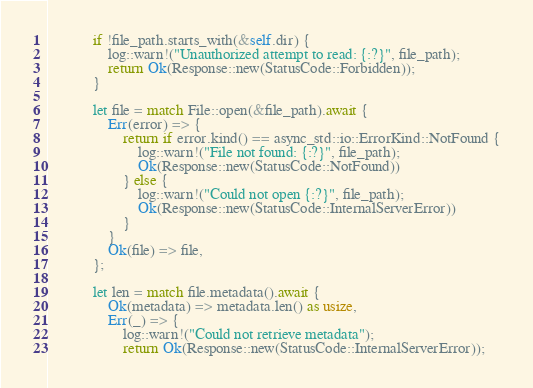Convert code to text. <code><loc_0><loc_0><loc_500><loc_500><_Rust_>            if !file_path.starts_with(&self.dir) {
                log::warn!("Unauthorized attempt to read: {:?}", file_path);
                return Ok(Response::new(StatusCode::Forbidden));
            }

            let file = match File::open(&file_path).await {
                Err(error) => {
                    return if error.kind() == async_std::io::ErrorKind::NotFound {
                        log::warn!("File not found: {:?}", file_path);
                        Ok(Response::new(StatusCode::NotFound))
                    } else {
                        log::warn!("Could not open {:?}", file_path);
                        Ok(Response::new(StatusCode::InternalServerError))
                    }
                }
                Ok(file) => file,
            };

            let len = match file.metadata().await {
                Ok(metadata) => metadata.len() as usize,
                Err(_) => {
                    log::warn!("Could not retrieve metadata");
                    return Ok(Response::new(StatusCode::InternalServerError));</code> 